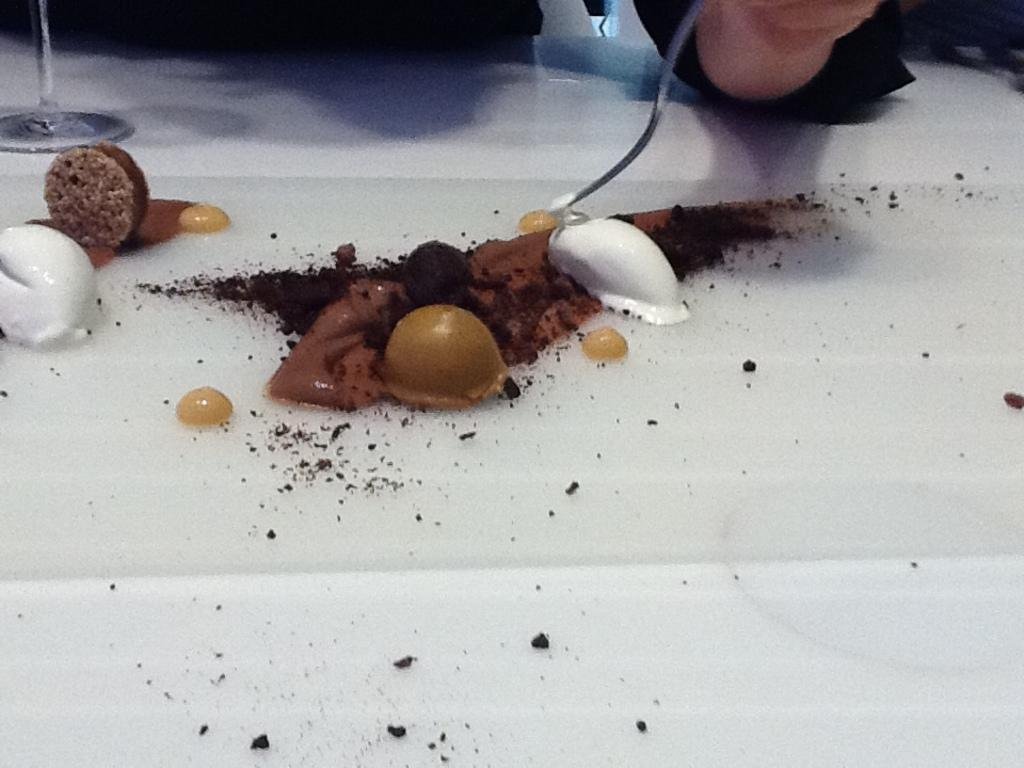What is present in the image that can be eaten? There are food items in the image. What is the color of the surface on which the food items are placed? The food items are on a white surface. Can you see any part of a person in the image? Yes, there is a person's hand visible in the image. What type of wren can be seen building a structure in the image? There is no wren or structure present in the image; it features food items on a white surface and a person's hand. How does the person's hand stretch in the image? The person's hand is not shown stretching in the image; it is simply visible. 